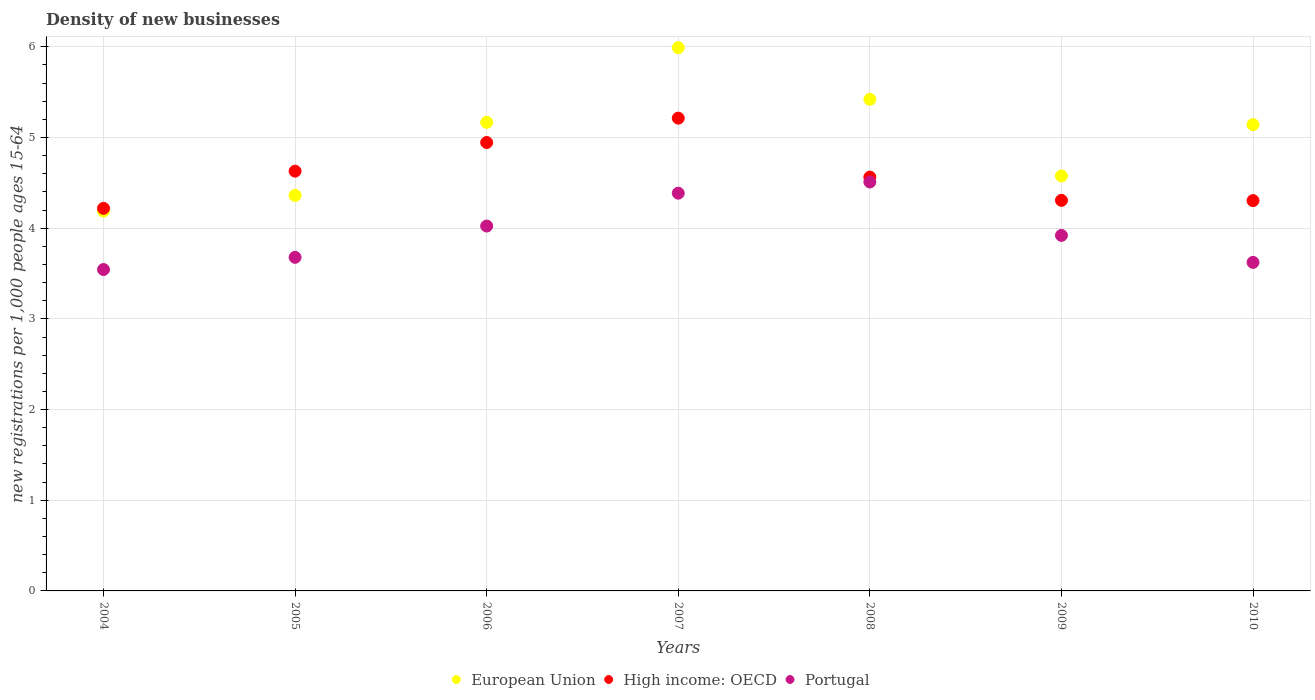Is the number of dotlines equal to the number of legend labels?
Your answer should be compact. Yes. What is the number of new registrations in European Union in 2010?
Your answer should be very brief. 5.14. Across all years, what is the maximum number of new registrations in Portugal?
Your response must be concise. 4.51. Across all years, what is the minimum number of new registrations in European Union?
Offer a terse response. 4.19. In which year was the number of new registrations in Portugal maximum?
Offer a terse response. 2008. In which year was the number of new registrations in European Union minimum?
Your answer should be compact. 2004. What is the total number of new registrations in European Union in the graph?
Your response must be concise. 34.85. What is the difference between the number of new registrations in European Union in 2006 and that in 2009?
Give a very brief answer. 0.59. What is the difference between the number of new registrations in Portugal in 2004 and the number of new registrations in High income: OECD in 2008?
Provide a succinct answer. -1.02. What is the average number of new registrations in Portugal per year?
Your answer should be very brief. 3.96. In the year 2009, what is the difference between the number of new registrations in High income: OECD and number of new registrations in European Union?
Offer a very short reply. -0.27. In how many years, is the number of new registrations in European Union greater than 4.6?
Ensure brevity in your answer.  4. What is the ratio of the number of new registrations in European Union in 2004 to that in 2008?
Keep it short and to the point. 0.77. Is the number of new registrations in High income: OECD in 2006 less than that in 2007?
Provide a short and direct response. Yes. What is the difference between the highest and the second highest number of new registrations in High income: OECD?
Your answer should be very brief. 0.27. What is the difference between the highest and the lowest number of new registrations in Portugal?
Keep it short and to the point. 0.97. In how many years, is the number of new registrations in European Union greater than the average number of new registrations in European Union taken over all years?
Offer a very short reply. 4. Is the number of new registrations in High income: OECD strictly greater than the number of new registrations in Portugal over the years?
Give a very brief answer. Yes. Are the values on the major ticks of Y-axis written in scientific E-notation?
Offer a terse response. No. Does the graph contain any zero values?
Give a very brief answer. No. What is the title of the graph?
Your answer should be compact. Density of new businesses. What is the label or title of the Y-axis?
Provide a succinct answer. New registrations per 1,0 people ages 15-64. What is the new registrations per 1,000 people ages 15-64 of European Union in 2004?
Your answer should be very brief. 4.19. What is the new registrations per 1,000 people ages 15-64 in High income: OECD in 2004?
Make the answer very short. 4.22. What is the new registrations per 1,000 people ages 15-64 of Portugal in 2004?
Offer a terse response. 3.54. What is the new registrations per 1,000 people ages 15-64 in European Union in 2005?
Ensure brevity in your answer.  4.36. What is the new registrations per 1,000 people ages 15-64 in High income: OECD in 2005?
Your answer should be very brief. 4.63. What is the new registrations per 1,000 people ages 15-64 in Portugal in 2005?
Make the answer very short. 3.68. What is the new registrations per 1,000 people ages 15-64 of European Union in 2006?
Offer a very short reply. 5.17. What is the new registrations per 1,000 people ages 15-64 of High income: OECD in 2006?
Keep it short and to the point. 4.94. What is the new registrations per 1,000 people ages 15-64 of Portugal in 2006?
Offer a terse response. 4.02. What is the new registrations per 1,000 people ages 15-64 in European Union in 2007?
Provide a short and direct response. 5.99. What is the new registrations per 1,000 people ages 15-64 of High income: OECD in 2007?
Keep it short and to the point. 5.21. What is the new registrations per 1,000 people ages 15-64 in Portugal in 2007?
Keep it short and to the point. 4.39. What is the new registrations per 1,000 people ages 15-64 of European Union in 2008?
Ensure brevity in your answer.  5.42. What is the new registrations per 1,000 people ages 15-64 of High income: OECD in 2008?
Offer a terse response. 4.56. What is the new registrations per 1,000 people ages 15-64 in Portugal in 2008?
Provide a short and direct response. 4.51. What is the new registrations per 1,000 people ages 15-64 of European Union in 2009?
Give a very brief answer. 4.58. What is the new registrations per 1,000 people ages 15-64 of High income: OECD in 2009?
Provide a short and direct response. 4.31. What is the new registrations per 1,000 people ages 15-64 in Portugal in 2009?
Offer a very short reply. 3.92. What is the new registrations per 1,000 people ages 15-64 of European Union in 2010?
Offer a very short reply. 5.14. What is the new registrations per 1,000 people ages 15-64 in High income: OECD in 2010?
Provide a succinct answer. 4.3. What is the new registrations per 1,000 people ages 15-64 of Portugal in 2010?
Provide a short and direct response. 3.62. Across all years, what is the maximum new registrations per 1,000 people ages 15-64 in European Union?
Offer a terse response. 5.99. Across all years, what is the maximum new registrations per 1,000 people ages 15-64 in High income: OECD?
Make the answer very short. 5.21. Across all years, what is the maximum new registrations per 1,000 people ages 15-64 of Portugal?
Keep it short and to the point. 4.51. Across all years, what is the minimum new registrations per 1,000 people ages 15-64 in European Union?
Make the answer very short. 4.19. Across all years, what is the minimum new registrations per 1,000 people ages 15-64 of High income: OECD?
Your answer should be compact. 4.22. Across all years, what is the minimum new registrations per 1,000 people ages 15-64 in Portugal?
Offer a very short reply. 3.54. What is the total new registrations per 1,000 people ages 15-64 of European Union in the graph?
Your answer should be compact. 34.85. What is the total new registrations per 1,000 people ages 15-64 of High income: OECD in the graph?
Your answer should be very brief. 32.18. What is the total new registrations per 1,000 people ages 15-64 of Portugal in the graph?
Provide a succinct answer. 27.69. What is the difference between the new registrations per 1,000 people ages 15-64 in European Union in 2004 and that in 2005?
Your answer should be very brief. -0.17. What is the difference between the new registrations per 1,000 people ages 15-64 in High income: OECD in 2004 and that in 2005?
Provide a succinct answer. -0.41. What is the difference between the new registrations per 1,000 people ages 15-64 in Portugal in 2004 and that in 2005?
Your answer should be compact. -0.13. What is the difference between the new registrations per 1,000 people ages 15-64 in European Union in 2004 and that in 2006?
Offer a terse response. -0.98. What is the difference between the new registrations per 1,000 people ages 15-64 of High income: OECD in 2004 and that in 2006?
Offer a very short reply. -0.73. What is the difference between the new registrations per 1,000 people ages 15-64 of Portugal in 2004 and that in 2006?
Offer a terse response. -0.48. What is the difference between the new registrations per 1,000 people ages 15-64 of European Union in 2004 and that in 2007?
Your response must be concise. -1.8. What is the difference between the new registrations per 1,000 people ages 15-64 of High income: OECD in 2004 and that in 2007?
Give a very brief answer. -0.99. What is the difference between the new registrations per 1,000 people ages 15-64 of Portugal in 2004 and that in 2007?
Provide a succinct answer. -0.84. What is the difference between the new registrations per 1,000 people ages 15-64 of European Union in 2004 and that in 2008?
Offer a very short reply. -1.23. What is the difference between the new registrations per 1,000 people ages 15-64 of High income: OECD in 2004 and that in 2008?
Ensure brevity in your answer.  -0.34. What is the difference between the new registrations per 1,000 people ages 15-64 in Portugal in 2004 and that in 2008?
Keep it short and to the point. -0.97. What is the difference between the new registrations per 1,000 people ages 15-64 in European Union in 2004 and that in 2009?
Provide a short and direct response. -0.39. What is the difference between the new registrations per 1,000 people ages 15-64 of High income: OECD in 2004 and that in 2009?
Give a very brief answer. -0.09. What is the difference between the new registrations per 1,000 people ages 15-64 of Portugal in 2004 and that in 2009?
Your answer should be very brief. -0.38. What is the difference between the new registrations per 1,000 people ages 15-64 of European Union in 2004 and that in 2010?
Provide a succinct answer. -0.95. What is the difference between the new registrations per 1,000 people ages 15-64 in High income: OECD in 2004 and that in 2010?
Offer a terse response. -0.09. What is the difference between the new registrations per 1,000 people ages 15-64 of Portugal in 2004 and that in 2010?
Your answer should be very brief. -0.08. What is the difference between the new registrations per 1,000 people ages 15-64 in European Union in 2005 and that in 2006?
Offer a terse response. -0.81. What is the difference between the new registrations per 1,000 people ages 15-64 in High income: OECD in 2005 and that in 2006?
Give a very brief answer. -0.32. What is the difference between the new registrations per 1,000 people ages 15-64 of Portugal in 2005 and that in 2006?
Provide a succinct answer. -0.35. What is the difference between the new registrations per 1,000 people ages 15-64 in European Union in 2005 and that in 2007?
Provide a short and direct response. -1.63. What is the difference between the new registrations per 1,000 people ages 15-64 in High income: OECD in 2005 and that in 2007?
Provide a succinct answer. -0.58. What is the difference between the new registrations per 1,000 people ages 15-64 in Portugal in 2005 and that in 2007?
Provide a succinct answer. -0.71. What is the difference between the new registrations per 1,000 people ages 15-64 in European Union in 2005 and that in 2008?
Give a very brief answer. -1.06. What is the difference between the new registrations per 1,000 people ages 15-64 of High income: OECD in 2005 and that in 2008?
Provide a succinct answer. 0.07. What is the difference between the new registrations per 1,000 people ages 15-64 of Portugal in 2005 and that in 2008?
Keep it short and to the point. -0.83. What is the difference between the new registrations per 1,000 people ages 15-64 in European Union in 2005 and that in 2009?
Offer a very short reply. -0.21. What is the difference between the new registrations per 1,000 people ages 15-64 of High income: OECD in 2005 and that in 2009?
Provide a short and direct response. 0.32. What is the difference between the new registrations per 1,000 people ages 15-64 of Portugal in 2005 and that in 2009?
Offer a very short reply. -0.24. What is the difference between the new registrations per 1,000 people ages 15-64 of European Union in 2005 and that in 2010?
Give a very brief answer. -0.78. What is the difference between the new registrations per 1,000 people ages 15-64 in High income: OECD in 2005 and that in 2010?
Provide a short and direct response. 0.33. What is the difference between the new registrations per 1,000 people ages 15-64 of Portugal in 2005 and that in 2010?
Make the answer very short. 0.06. What is the difference between the new registrations per 1,000 people ages 15-64 of European Union in 2006 and that in 2007?
Your response must be concise. -0.82. What is the difference between the new registrations per 1,000 people ages 15-64 in High income: OECD in 2006 and that in 2007?
Make the answer very short. -0.27. What is the difference between the new registrations per 1,000 people ages 15-64 in Portugal in 2006 and that in 2007?
Offer a very short reply. -0.36. What is the difference between the new registrations per 1,000 people ages 15-64 of European Union in 2006 and that in 2008?
Make the answer very short. -0.25. What is the difference between the new registrations per 1,000 people ages 15-64 in High income: OECD in 2006 and that in 2008?
Make the answer very short. 0.38. What is the difference between the new registrations per 1,000 people ages 15-64 of Portugal in 2006 and that in 2008?
Offer a terse response. -0.49. What is the difference between the new registrations per 1,000 people ages 15-64 of European Union in 2006 and that in 2009?
Your response must be concise. 0.59. What is the difference between the new registrations per 1,000 people ages 15-64 in High income: OECD in 2006 and that in 2009?
Offer a terse response. 0.64. What is the difference between the new registrations per 1,000 people ages 15-64 of Portugal in 2006 and that in 2009?
Offer a terse response. 0.1. What is the difference between the new registrations per 1,000 people ages 15-64 of European Union in 2006 and that in 2010?
Your response must be concise. 0.03. What is the difference between the new registrations per 1,000 people ages 15-64 of High income: OECD in 2006 and that in 2010?
Provide a short and direct response. 0.64. What is the difference between the new registrations per 1,000 people ages 15-64 in Portugal in 2006 and that in 2010?
Keep it short and to the point. 0.4. What is the difference between the new registrations per 1,000 people ages 15-64 in European Union in 2007 and that in 2008?
Ensure brevity in your answer.  0.57. What is the difference between the new registrations per 1,000 people ages 15-64 in High income: OECD in 2007 and that in 2008?
Keep it short and to the point. 0.65. What is the difference between the new registrations per 1,000 people ages 15-64 in Portugal in 2007 and that in 2008?
Provide a succinct answer. -0.12. What is the difference between the new registrations per 1,000 people ages 15-64 in European Union in 2007 and that in 2009?
Your answer should be very brief. 1.41. What is the difference between the new registrations per 1,000 people ages 15-64 of High income: OECD in 2007 and that in 2009?
Offer a very short reply. 0.91. What is the difference between the new registrations per 1,000 people ages 15-64 of Portugal in 2007 and that in 2009?
Give a very brief answer. 0.47. What is the difference between the new registrations per 1,000 people ages 15-64 of European Union in 2007 and that in 2010?
Ensure brevity in your answer.  0.85. What is the difference between the new registrations per 1,000 people ages 15-64 of High income: OECD in 2007 and that in 2010?
Your answer should be compact. 0.91. What is the difference between the new registrations per 1,000 people ages 15-64 of Portugal in 2007 and that in 2010?
Ensure brevity in your answer.  0.76. What is the difference between the new registrations per 1,000 people ages 15-64 of European Union in 2008 and that in 2009?
Make the answer very short. 0.85. What is the difference between the new registrations per 1,000 people ages 15-64 in High income: OECD in 2008 and that in 2009?
Your response must be concise. 0.26. What is the difference between the new registrations per 1,000 people ages 15-64 of Portugal in 2008 and that in 2009?
Make the answer very short. 0.59. What is the difference between the new registrations per 1,000 people ages 15-64 in European Union in 2008 and that in 2010?
Ensure brevity in your answer.  0.28. What is the difference between the new registrations per 1,000 people ages 15-64 of High income: OECD in 2008 and that in 2010?
Provide a short and direct response. 0.26. What is the difference between the new registrations per 1,000 people ages 15-64 of Portugal in 2008 and that in 2010?
Your response must be concise. 0.89. What is the difference between the new registrations per 1,000 people ages 15-64 in European Union in 2009 and that in 2010?
Ensure brevity in your answer.  -0.57. What is the difference between the new registrations per 1,000 people ages 15-64 of High income: OECD in 2009 and that in 2010?
Your answer should be compact. 0. What is the difference between the new registrations per 1,000 people ages 15-64 of Portugal in 2009 and that in 2010?
Your answer should be very brief. 0.3. What is the difference between the new registrations per 1,000 people ages 15-64 of European Union in 2004 and the new registrations per 1,000 people ages 15-64 of High income: OECD in 2005?
Your answer should be compact. -0.44. What is the difference between the new registrations per 1,000 people ages 15-64 in European Union in 2004 and the new registrations per 1,000 people ages 15-64 in Portugal in 2005?
Ensure brevity in your answer.  0.51. What is the difference between the new registrations per 1,000 people ages 15-64 of High income: OECD in 2004 and the new registrations per 1,000 people ages 15-64 of Portugal in 2005?
Your response must be concise. 0.54. What is the difference between the new registrations per 1,000 people ages 15-64 of European Union in 2004 and the new registrations per 1,000 people ages 15-64 of High income: OECD in 2006?
Offer a very short reply. -0.76. What is the difference between the new registrations per 1,000 people ages 15-64 of European Union in 2004 and the new registrations per 1,000 people ages 15-64 of Portugal in 2006?
Provide a short and direct response. 0.17. What is the difference between the new registrations per 1,000 people ages 15-64 of High income: OECD in 2004 and the new registrations per 1,000 people ages 15-64 of Portugal in 2006?
Keep it short and to the point. 0.2. What is the difference between the new registrations per 1,000 people ages 15-64 of European Union in 2004 and the new registrations per 1,000 people ages 15-64 of High income: OECD in 2007?
Your answer should be very brief. -1.02. What is the difference between the new registrations per 1,000 people ages 15-64 of European Union in 2004 and the new registrations per 1,000 people ages 15-64 of Portugal in 2007?
Give a very brief answer. -0.2. What is the difference between the new registrations per 1,000 people ages 15-64 in High income: OECD in 2004 and the new registrations per 1,000 people ages 15-64 in Portugal in 2007?
Give a very brief answer. -0.17. What is the difference between the new registrations per 1,000 people ages 15-64 of European Union in 2004 and the new registrations per 1,000 people ages 15-64 of High income: OECD in 2008?
Provide a succinct answer. -0.37. What is the difference between the new registrations per 1,000 people ages 15-64 in European Union in 2004 and the new registrations per 1,000 people ages 15-64 in Portugal in 2008?
Ensure brevity in your answer.  -0.32. What is the difference between the new registrations per 1,000 people ages 15-64 in High income: OECD in 2004 and the new registrations per 1,000 people ages 15-64 in Portugal in 2008?
Your answer should be very brief. -0.29. What is the difference between the new registrations per 1,000 people ages 15-64 in European Union in 2004 and the new registrations per 1,000 people ages 15-64 in High income: OECD in 2009?
Provide a succinct answer. -0.12. What is the difference between the new registrations per 1,000 people ages 15-64 in European Union in 2004 and the new registrations per 1,000 people ages 15-64 in Portugal in 2009?
Offer a terse response. 0.27. What is the difference between the new registrations per 1,000 people ages 15-64 of High income: OECD in 2004 and the new registrations per 1,000 people ages 15-64 of Portugal in 2009?
Offer a very short reply. 0.3. What is the difference between the new registrations per 1,000 people ages 15-64 in European Union in 2004 and the new registrations per 1,000 people ages 15-64 in High income: OECD in 2010?
Make the answer very short. -0.12. What is the difference between the new registrations per 1,000 people ages 15-64 in European Union in 2004 and the new registrations per 1,000 people ages 15-64 in Portugal in 2010?
Keep it short and to the point. 0.57. What is the difference between the new registrations per 1,000 people ages 15-64 of High income: OECD in 2004 and the new registrations per 1,000 people ages 15-64 of Portugal in 2010?
Your answer should be compact. 0.6. What is the difference between the new registrations per 1,000 people ages 15-64 in European Union in 2005 and the new registrations per 1,000 people ages 15-64 in High income: OECD in 2006?
Your response must be concise. -0.58. What is the difference between the new registrations per 1,000 people ages 15-64 of European Union in 2005 and the new registrations per 1,000 people ages 15-64 of Portugal in 2006?
Make the answer very short. 0.34. What is the difference between the new registrations per 1,000 people ages 15-64 in High income: OECD in 2005 and the new registrations per 1,000 people ages 15-64 in Portugal in 2006?
Ensure brevity in your answer.  0.61. What is the difference between the new registrations per 1,000 people ages 15-64 of European Union in 2005 and the new registrations per 1,000 people ages 15-64 of High income: OECD in 2007?
Give a very brief answer. -0.85. What is the difference between the new registrations per 1,000 people ages 15-64 in European Union in 2005 and the new registrations per 1,000 people ages 15-64 in Portugal in 2007?
Ensure brevity in your answer.  -0.02. What is the difference between the new registrations per 1,000 people ages 15-64 in High income: OECD in 2005 and the new registrations per 1,000 people ages 15-64 in Portugal in 2007?
Keep it short and to the point. 0.24. What is the difference between the new registrations per 1,000 people ages 15-64 in European Union in 2005 and the new registrations per 1,000 people ages 15-64 in High income: OECD in 2008?
Offer a terse response. -0.2. What is the difference between the new registrations per 1,000 people ages 15-64 in European Union in 2005 and the new registrations per 1,000 people ages 15-64 in Portugal in 2008?
Your answer should be compact. -0.15. What is the difference between the new registrations per 1,000 people ages 15-64 of High income: OECD in 2005 and the new registrations per 1,000 people ages 15-64 of Portugal in 2008?
Make the answer very short. 0.12. What is the difference between the new registrations per 1,000 people ages 15-64 in European Union in 2005 and the new registrations per 1,000 people ages 15-64 in High income: OECD in 2009?
Provide a succinct answer. 0.05. What is the difference between the new registrations per 1,000 people ages 15-64 in European Union in 2005 and the new registrations per 1,000 people ages 15-64 in Portugal in 2009?
Your answer should be very brief. 0.44. What is the difference between the new registrations per 1,000 people ages 15-64 of High income: OECD in 2005 and the new registrations per 1,000 people ages 15-64 of Portugal in 2009?
Keep it short and to the point. 0.71. What is the difference between the new registrations per 1,000 people ages 15-64 in European Union in 2005 and the new registrations per 1,000 people ages 15-64 in High income: OECD in 2010?
Give a very brief answer. 0.06. What is the difference between the new registrations per 1,000 people ages 15-64 of European Union in 2005 and the new registrations per 1,000 people ages 15-64 of Portugal in 2010?
Offer a terse response. 0.74. What is the difference between the new registrations per 1,000 people ages 15-64 in High income: OECD in 2005 and the new registrations per 1,000 people ages 15-64 in Portugal in 2010?
Keep it short and to the point. 1.01. What is the difference between the new registrations per 1,000 people ages 15-64 in European Union in 2006 and the new registrations per 1,000 people ages 15-64 in High income: OECD in 2007?
Keep it short and to the point. -0.05. What is the difference between the new registrations per 1,000 people ages 15-64 of European Union in 2006 and the new registrations per 1,000 people ages 15-64 of Portugal in 2007?
Offer a very short reply. 0.78. What is the difference between the new registrations per 1,000 people ages 15-64 of High income: OECD in 2006 and the new registrations per 1,000 people ages 15-64 of Portugal in 2007?
Give a very brief answer. 0.56. What is the difference between the new registrations per 1,000 people ages 15-64 of European Union in 2006 and the new registrations per 1,000 people ages 15-64 of High income: OECD in 2008?
Ensure brevity in your answer.  0.6. What is the difference between the new registrations per 1,000 people ages 15-64 of European Union in 2006 and the new registrations per 1,000 people ages 15-64 of Portugal in 2008?
Offer a very short reply. 0.66. What is the difference between the new registrations per 1,000 people ages 15-64 in High income: OECD in 2006 and the new registrations per 1,000 people ages 15-64 in Portugal in 2008?
Provide a succinct answer. 0.44. What is the difference between the new registrations per 1,000 people ages 15-64 of European Union in 2006 and the new registrations per 1,000 people ages 15-64 of High income: OECD in 2009?
Give a very brief answer. 0.86. What is the difference between the new registrations per 1,000 people ages 15-64 of European Union in 2006 and the new registrations per 1,000 people ages 15-64 of Portugal in 2009?
Offer a very short reply. 1.25. What is the difference between the new registrations per 1,000 people ages 15-64 of High income: OECD in 2006 and the new registrations per 1,000 people ages 15-64 of Portugal in 2009?
Make the answer very short. 1.02. What is the difference between the new registrations per 1,000 people ages 15-64 in European Union in 2006 and the new registrations per 1,000 people ages 15-64 in High income: OECD in 2010?
Ensure brevity in your answer.  0.86. What is the difference between the new registrations per 1,000 people ages 15-64 in European Union in 2006 and the new registrations per 1,000 people ages 15-64 in Portugal in 2010?
Ensure brevity in your answer.  1.54. What is the difference between the new registrations per 1,000 people ages 15-64 of High income: OECD in 2006 and the new registrations per 1,000 people ages 15-64 of Portugal in 2010?
Provide a short and direct response. 1.32. What is the difference between the new registrations per 1,000 people ages 15-64 in European Union in 2007 and the new registrations per 1,000 people ages 15-64 in High income: OECD in 2008?
Your response must be concise. 1.43. What is the difference between the new registrations per 1,000 people ages 15-64 of European Union in 2007 and the new registrations per 1,000 people ages 15-64 of Portugal in 2008?
Your response must be concise. 1.48. What is the difference between the new registrations per 1,000 people ages 15-64 of High income: OECD in 2007 and the new registrations per 1,000 people ages 15-64 of Portugal in 2008?
Offer a very short reply. 0.7. What is the difference between the new registrations per 1,000 people ages 15-64 of European Union in 2007 and the new registrations per 1,000 people ages 15-64 of High income: OECD in 2009?
Your response must be concise. 1.68. What is the difference between the new registrations per 1,000 people ages 15-64 of European Union in 2007 and the new registrations per 1,000 people ages 15-64 of Portugal in 2009?
Your response must be concise. 2.07. What is the difference between the new registrations per 1,000 people ages 15-64 in High income: OECD in 2007 and the new registrations per 1,000 people ages 15-64 in Portugal in 2009?
Your answer should be compact. 1.29. What is the difference between the new registrations per 1,000 people ages 15-64 in European Union in 2007 and the new registrations per 1,000 people ages 15-64 in High income: OECD in 2010?
Offer a very short reply. 1.69. What is the difference between the new registrations per 1,000 people ages 15-64 in European Union in 2007 and the new registrations per 1,000 people ages 15-64 in Portugal in 2010?
Provide a succinct answer. 2.37. What is the difference between the new registrations per 1,000 people ages 15-64 in High income: OECD in 2007 and the new registrations per 1,000 people ages 15-64 in Portugal in 2010?
Keep it short and to the point. 1.59. What is the difference between the new registrations per 1,000 people ages 15-64 of European Union in 2008 and the new registrations per 1,000 people ages 15-64 of High income: OECD in 2009?
Ensure brevity in your answer.  1.11. What is the difference between the new registrations per 1,000 people ages 15-64 of European Union in 2008 and the new registrations per 1,000 people ages 15-64 of Portugal in 2009?
Your answer should be compact. 1.5. What is the difference between the new registrations per 1,000 people ages 15-64 in High income: OECD in 2008 and the new registrations per 1,000 people ages 15-64 in Portugal in 2009?
Offer a very short reply. 0.64. What is the difference between the new registrations per 1,000 people ages 15-64 in European Union in 2008 and the new registrations per 1,000 people ages 15-64 in High income: OECD in 2010?
Keep it short and to the point. 1.12. What is the difference between the new registrations per 1,000 people ages 15-64 in European Union in 2008 and the new registrations per 1,000 people ages 15-64 in Portugal in 2010?
Provide a succinct answer. 1.8. What is the difference between the new registrations per 1,000 people ages 15-64 in High income: OECD in 2008 and the new registrations per 1,000 people ages 15-64 in Portugal in 2010?
Your response must be concise. 0.94. What is the difference between the new registrations per 1,000 people ages 15-64 in European Union in 2009 and the new registrations per 1,000 people ages 15-64 in High income: OECD in 2010?
Keep it short and to the point. 0.27. What is the difference between the new registrations per 1,000 people ages 15-64 of European Union in 2009 and the new registrations per 1,000 people ages 15-64 of Portugal in 2010?
Offer a very short reply. 0.95. What is the difference between the new registrations per 1,000 people ages 15-64 in High income: OECD in 2009 and the new registrations per 1,000 people ages 15-64 in Portugal in 2010?
Keep it short and to the point. 0.68. What is the average new registrations per 1,000 people ages 15-64 of European Union per year?
Ensure brevity in your answer.  4.98. What is the average new registrations per 1,000 people ages 15-64 of High income: OECD per year?
Your answer should be very brief. 4.6. What is the average new registrations per 1,000 people ages 15-64 in Portugal per year?
Offer a very short reply. 3.96. In the year 2004, what is the difference between the new registrations per 1,000 people ages 15-64 of European Union and new registrations per 1,000 people ages 15-64 of High income: OECD?
Your answer should be very brief. -0.03. In the year 2004, what is the difference between the new registrations per 1,000 people ages 15-64 of European Union and new registrations per 1,000 people ages 15-64 of Portugal?
Offer a very short reply. 0.64. In the year 2004, what is the difference between the new registrations per 1,000 people ages 15-64 in High income: OECD and new registrations per 1,000 people ages 15-64 in Portugal?
Keep it short and to the point. 0.67. In the year 2005, what is the difference between the new registrations per 1,000 people ages 15-64 in European Union and new registrations per 1,000 people ages 15-64 in High income: OECD?
Make the answer very short. -0.27. In the year 2005, what is the difference between the new registrations per 1,000 people ages 15-64 of European Union and new registrations per 1,000 people ages 15-64 of Portugal?
Your response must be concise. 0.68. In the year 2005, what is the difference between the new registrations per 1,000 people ages 15-64 of High income: OECD and new registrations per 1,000 people ages 15-64 of Portugal?
Offer a very short reply. 0.95. In the year 2006, what is the difference between the new registrations per 1,000 people ages 15-64 in European Union and new registrations per 1,000 people ages 15-64 in High income: OECD?
Provide a short and direct response. 0.22. In the year 2006, what is the difference between the new registrations per 1,000 people ages 15-64 of European Union and new registrations per 1,000 people ages 15-64 of Portugal?
Make the answer very short. 1.14. In the year 2006, what is the difference between the new registrations per 1,000 people ages 15-64 of High income: OECD and new registrations per 1,000 people ages 15-64 of Portugal?
Your answer should be very brief. 0.92. In the year 2007, what is the difference between the new registrations per 1,000 people ages 15-64 in European Union and new registrations per 1,000 people ages 15-64 in High income: OECD?
Ensure brevity in your answer.  0.78. In the year 2007, what is the difference between the new registrations per 1,000 people ages 15-64 in European Union and new registrations per 1,000 people ages 15-64 in Portugal?
Give a very brief answer. 1.6. In the year 2007, what is the difference between the new registrations per 1,000 people ages 15-64 in High income: OECD and new registrations per 1,000 people ages 15-64 in Portugal?
Ensure brevity in your answer.  0.83. In the year 2008, what is the difference between the new registrations per 1,000 people ages 15-64 in European Union and new registrations per 1,000 people ages 15-64 in High income: OECD?
Provide a short and direct response. 0.86. In the year 2008, what is the difference between the new registrations per 1,000 people ages 15-64 of European Union and new registrations per 1,000 people ages 15-64 of Portugal?
Keep it short and to the point. 0.91. In the year 2008, what is the difference between the new registrations per 1,000 people ages 15-64 of High income: OECD and new registrations per 1,000 people ages 15-64 of Portugal?
Make the answer very short. 0.05. In the year 2009, what is the difference between the new registrations per 1,000 people ages 15-64 of European Union and new registrations per 1,000 people ages 15-64 of High income: OECD?
Ensure brevity in your answer.  0.27. In the year 2009, what is the difference between the new registrations per 1,000 people ages 15-64 in European Union and new registrations per 1,000 people ages 15-64 in Portugal?
Give a very brief answer. 0.66. In the year 2009, what is the difference between the new registrations per 1,000 people ages 15-64 in High income: OECD and new registrations per 1,000 people ages 15-64 in Portugal?
Keep it short and to the point. 0.39. In the year 2010, what is the difference between the new registrations per 1,000 people ages 15-64 in European Union and new registrations per 1,000 people ages 15-64 in High income: OECD?
Provide a short and direct response. 0.84. In the year 2010, what is the difference between the new registrations per 1,000 people ages 15-64 in European Union and new registrations per 1,000 people ages 15-64 in Portugal?
Ensure brevity in your answer.  1.52. In the year 2010, what is the difference between the new registrations per 1,000 people ages 15-64 of High income: OECD and new registrations per 1,000 people ages 15-64 of Portugal?
Your response must be concise. 0.68. What is the ratio of the new registrations per 1,000 people ages 15-64 of European Union in 2004 to that in 2005?
Your answer should be very brief. 0.96. What is the ratio of the new registrations per 1,000 people ages 15-64 of High income: OECD in 2004 to that in 2005?
Provide a short and direct response. 0.91. What is the ratio of the new registrations per 1,000 people ages 15-64 of Portugal in 2004 to that in 2005?
Provide a succinct answer. 0.96. What is the ratio of the new registrations per 1,000 people ages 15-64 in European Union in 2004 to that in 2006?
Make the answer very short. 0.81. What is the ratio of the new registrations per 1,000 people ages 15-64 of High income: OECD in 2004 to that in 2006?
Offer a very short reply. 0.85. What is the ratio of the new registrations per 1,000 people ages 15-64 of Portugal in 2004 to that in 2006?
Provide a succinct answer. 0.88. What is the ratio of the new registrations per 1,000 people ages 15-64 in European Union in 2004 to that in 2007?
Make the answer very short. 0.7. What is the ratio of the new registrations per 1,000 people ages 15-64 of High income: OECD in 2004 to that in 2007?
Your answer should be compact. 0.81. What is the ratio of the new registrations per 1,000 people ages 15-64 in Portugal in 2004 to that in 2007?
Keep it short and to the point. 0.81. What is the ratio of the new registrations per 1,000 people ages 15-64 in European Union in 2004 to that in 2008?
Your response must be concise. 0.77. What is the ratio of the new registrations per 1,000 people ages 15-64 of High income: OECD in 2004 to that in 2008?
Your answer should be compact. 0.92. What is the ratio of the new registrations per 1,000 people ages 15-64 of Portugal in 2004 to that in 2008?
Offer a terse response. 0.79. What is the ratio of the new registrations per 1,000 people ages 15-64 in European Union in 2004 to that in 2009?
Your answer should be compact. 0.92. What is the ratio of the new registrations per 1,000 people ages 15-64 of High income: OECD in 2004 to that in 2009?
Your answer should be compact. 0.98. What is the ratio of the new registrations per 1,000 people ages 15-64 of Portugal in 2004 to that in 2009?
Ensure brevity in your answer.  0.9. What is the ratio of the new registrations per 1,000 people ages 15-64 of European Union in 2004 to that in 2010?
Your response must be concise. 0.81. What is the ratio of the new registrations per 1,000 people ages 15-64 in High income: OECD in 2004 to that in 2010?
Give a very brief answer. 0.98. What is the ratio of the new registrations per 1,000 people ages 15-64 of Portugal in 2004 to that in 2010?
Your answer should be very brief. 0.98. What is the ratio of the new registrations per 1,000 people ages 15-64 in European Union in 2005 to that in 2006?
Keep it short and to the point. 0.84. What is the ratio of the new registrations per 1,000 people ages 15-64 in High income: OECD in 2005 to that in 2006?
Offer a very short reply. 0.94. What is the ratio of the new registrations per 1,000 people ages 15-64 in Portugal in 2005 to that in 2006?
Keep it short and to the point. 0.91. What is the ratio of the new registrations per 1,000 people ages 15-64 in European Union in 2005 to that in 2007?
Offer a very short reply. 0.73. What is the ratio of the new registrations per 1,000 people ages 15-64 in High income: OECD in 2005 to that in 2007?
Offer a very short reply. 0.89. What is the ratio of the new registrations per 1,000 people ages 15-64 of Portugal in 2005 to that in 2007?
Your response must be concise. 0.84. What is the ratio of the new registrations per 1,000 people ages 15-64 of European Union in 2005 to that in 2008?
Offer a terse response. 0.8. What is the ratio of the new registrations per 1,000 people ages 15-64 of High income: OECD in 2005 to that in 2008?
Keep it short and to the point. 1.01. What is the ratio of the new registrations per 1,000 people ages 15-64 of Portugal in 2005 to that in 2008?
Provide a short and direct response. 0.82. What is the ratio of the new registrations per 1,000 people ages 15-64 of European Union in 2005 to that in 2009?
Ensure brevity in your answer.  0.95. What is the ratio of the new registrations per 1,000 people ages 15-64 in High income: OECD in 2005 to that in 2009?
Your answer should be compact. 1.07. What is the ratio of the new registrations per 1,000 people ages 15-64 of Portugal in 2005 to that in 2009?
Make the answer very short. 0.94. What is the ratio of the new registrations per 1,000 people ages 15-64 in European Union in 2005 to that in 2010?
Offer a terse response. 0.85. What is the ratio of the new registrations per 1,000 people ages 15-64 in High income: OECD in 2005 to that in 2010?
Your answer should be very brief. 1.08. What is the ratio of the new registrations per 1,000 people ages 15-64 in Portugal in 2005 to that in 2010?
Offer a very short reply. 1.02. What is the ratio of the new registrations per 1,000 people ages 15-64 of European Union in 2006 to that in 2007?
Ensure brevity in your answer.  0.86. What is the ratio of the new registrations per 1,000 people ages 15-64 of High income: OECD in 2006 to that in 2007?
Your answer should be very brief. 0.95. What is the ratio of the new registrations per 1,000 people ages 15-64 of Portugal in 2006 to that in 2007?
Your answer should be very brief. 0.92. What is the ratio of the new registrations per 1,000 people ages 15-64 in European Union in 2006 to that in 2008?
Make the answer very short. 0.95. What is the ratio of the new registrations per 1,000 people ages 15-64 in High income: OECD in 2006 to that in 2008?
Your answer should be compact. 1.08. What is the ratio of the new registrations per 1,000 people ages 15-64 in Portugal in 2006 to that in 2008?
Your response must be concise. 0.89. What is the ratio of the new registrations per 1,000 people ages 15-64 of European Union in 2006 to that in 2009?
Your answer should be compact. 1.13. What is the ratio of the new registrations per 1,000 people ages 15-64 in High income: OECD in 2006 to that in 2009?
Ensure brevity in your answer.  1.15. What is the ratio of the new registrations per 1,000 people ages 15-64 in Portugal in 2006 to that in 2009?
Offer a terse response. 1.03. What is the ratio of the new registrations per 1,000 people ages 15-64 of European Union in 2006 to that in 2010?
Offer a very short reply. 1. What is the ratio of the new registrations per 1,000 people ages 15-64 of High income: OECD in 2006 to that in 2010?
Keep it short and to the point. 1.15. What is the ratio of the new registrations per 1,000 people ages 15-64 of Portugal in 2006 to that in 2010?
Your response must be concise. 1.11. What is the ratio of the new registrations per 1,000 people ages 15-64 of European Union in 2007 to that in 2008?
Give a very brief answer. 1.11. What is the ratio of the new registrations per 1,000 people ages 15-64 of High income: OECD in 2007 to that in 2008?
Your response must be concise. 1.14. What is the ratio of the new registrations per 1,000 people ages 15-64 in Portugal in 2007 to that in 2008?
Ensure brevity in your answer.  0.97. What is the ratio of the new registrations per 1,000 people ages 15-64 of European Union in 2007 to that in 2009?
Offer a very short reply. 1.31. What is the ratio of the new registrations per 1,000 people ages 15-64 of High income: OECD in 2007 to that in 2009?
Make the answer very short. 1.21. What is the ratio of the new registrations per 1,000 people ages 15-64 of Portugal in 2007 to that in 2009?
Offer a very short reply. 1.12. What is the ratio of the new registrations per 1,000 people ages 15-64 in European Union in 2007 to that in 2010?
Make the answer very short. 1.17. What is the ratio of the new registrations per 1,000 people ages 15-64 in High income: OECD in 2007 to that in 2010?
Make the answer very short. 1.21. What is the ratio of the new registrations per 1,000 people ages 15-64 of Portugal in 2007 to that in 2010?
Give a very brief answer. 1.21. What is the ratio of the new registrations per 1,000 people ages 15-64 of European Union in 2008 to that in 2009?
Keep it short and to the point. 1.18. What is the ratio of the new registrations per 1,000 people ages 15-64 in High income: OECD in 2008 to that in 2009?
Your response must be concise. 1.06. What is the ratio of the new registrations per 1,000 people ages 15-64 in Portugal in 2008 to that in 2009?
Make the answer very short. 1.15. What is the ratio of the new registrations per 1,000 people ages 15-64 in European Union in 2008 to that in 2010?
Your response must be concise. 1.05. What is the ratio of the new registrations per 1,000 people ages 15-64 of High income: OECD in 2008 to that in 2010?
Offer a very short reply. 1.06. What is the ratio of the new registrations per 1,000 people ages 15-64 in Portugal in 2008 to that in 2010?
Give a very brief answer. 1.24. What is the ratio of the new registrations per 1,000 people ages 15-64 in European Union in 2009 to that in 2010?
Make the answer very short. 0.89. What is the ratio of the new registrations per 1,000 people ages 15-64 of Portugal in 2009 to that in 2010?
Your answer should be compact. 1.08. What is the difference between the highest and the second highest new registrations per 1,000 people ages 15-64 in European Union?
Your answer should be very brief. 0.57. What is the difference between the highest and the second highest new registrations per 1,000 people ages 15-64 in High income: OECD?
Offer a very short reply. 0.27. What is the difference between the highest and the second highest new registrations per 1,000 people ages 15-64 of Portugal?
Make the answer very short. 0.12. What is the difference between the highest and the lowest new registrations per 1,000 people ages 15-64 in European Union?
Make the answer very short. 1.8. What is the difference between the highest and the lowest new registrations per 1,000 people ages 15-64 in Portugal?
Provide a succinct answer. 0.97. 